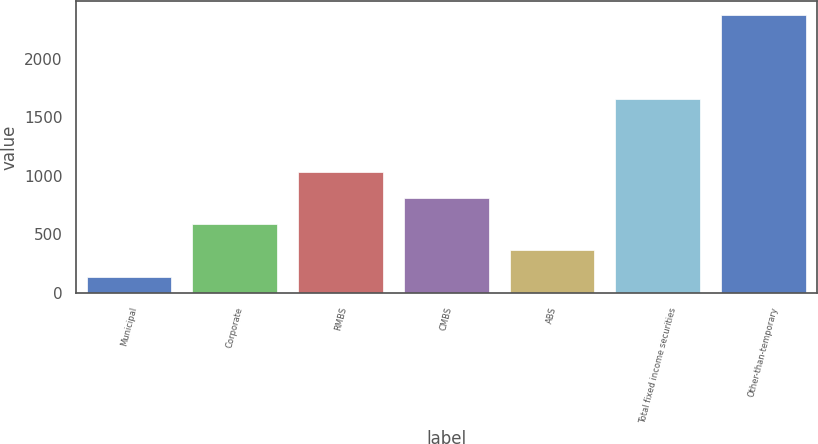Convert chart. <chart><loc_0><loc_0><loc_500><loc_500><bar_chart><fcel>Municipal<fcel>Corporate<fcel>RMBS<fcel>CMBS<fcel>ABS<fcel>Total fixed income securities<fcel>Other-than-temporary<nl><fcel>140<fcel>587.2<fcel>1034.4<fcel>810.8<fcel>363.6<fcel>1661<fcel>2376<nl></chart> 